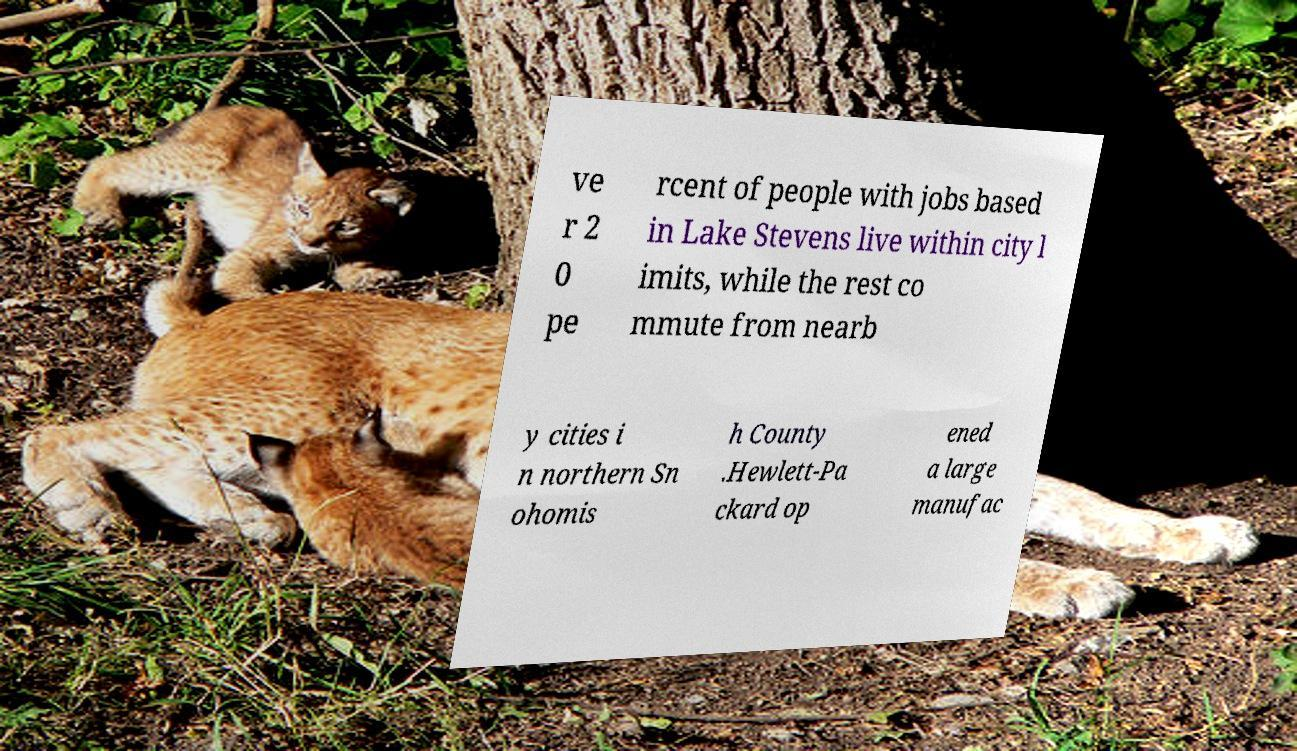There's text embedded in this image that I need extracted. Can you transcribe it verbatim? ve r 2 0 pe rcent of people with jobs based in Lake Stevens live within city l imits, while the rest co mmute from nearb y cities i n northern Sn ohomis h County .Hewlett-Pa ckard op ened a large manufac 